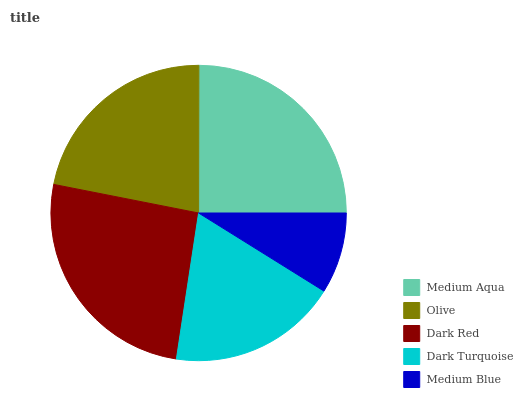Is Medium Blue the minimum?
Answer yes or no. Yes. Is Dark Red the maximum?
Answer yes or no. Yes. Is Olive the minimum?
Answer yes or no. No. Is Olive the maximum?
Answer yes or no. No. Is Medium Aqua greater than Olive?
Answer yes or no. Yes. Is Olive less than Medium Aqua?
Answer yes or no. Yes. Is Olive greater than Medium Aqua?
Answer yes or no. No. Is Medium Aqua less than Olive?
Answer yes or no. No. Is Olive the high median?
Answer yes or no. Yes. Is Olive the low median?
Answer yes or no. Yes. Is Dark Red the high median?
Answer yes or no. No. Is Dark Red the low median?
Answer yes or no. No. 